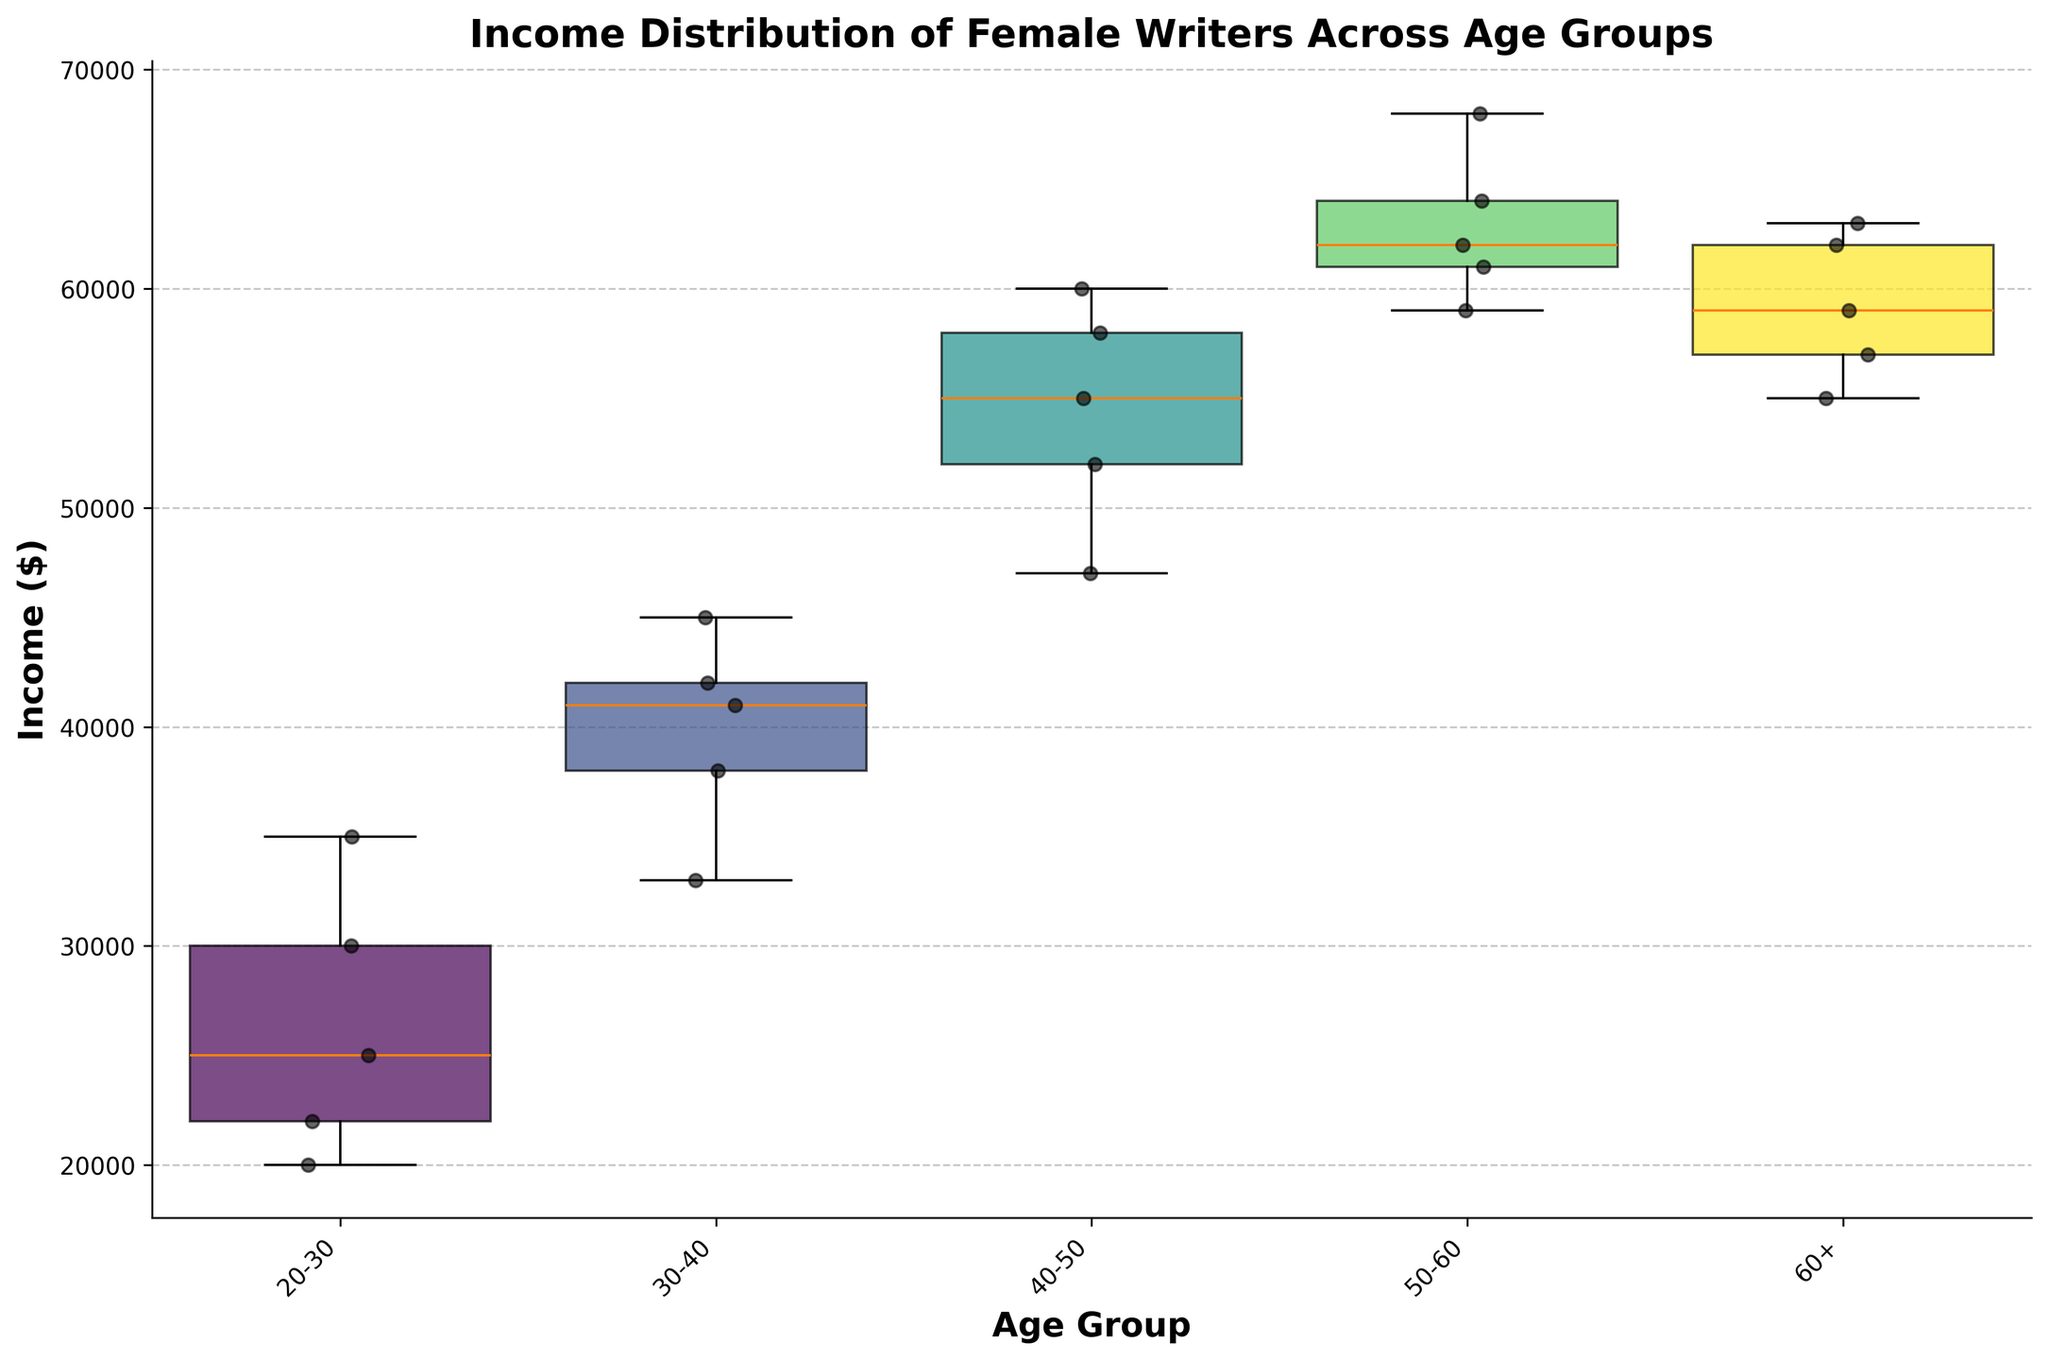What is the title of the figure? The title of the figure is typically located at the top center. It’s used to explain what the figure is about. Here, we can see that the title states "Income Distribution of Female Writers Across Age Groups".
Answer: Income Distribution of Female Writers Across Age Groups What does the x-axis represent? The x-axis label can be found on the horizontal line at the bottom of the plot. The label states that it represents "Age Group".
Answer: Age Group Which age group has the widest box plot? By observing the width of the box plots, the age group 20-30 has the widest box. The width corresponds to the number of data points for each age group.
Answer: 20-30 What is the general trend in median income across the different age groups? To identify the trend, observe the middle line (median) within each box. We can see that the median income tends to increase as the age group increases.
Answer: Median income increases with age Which age group shows the highest variability in income? Variability in income can be determined by looking at the interquartile range (IQR), which is the distance between the top and bottom of each box. The 50-60 age group has the largest IQR, indicating the highest variability.
Answer: 50-60 How does the number of data points affect the width of each box plot? Each box plot's width is determined by the number of data points within each age group. The wider the box plot, the more data points it includes. Age groups like 20-30 have more data points, making the box plot wider.
Answer: Wider boxes have more data points What is the median income for the 40-50 age group? The median is represented by the line within the 40-50 age group’s box. It appears to be around $55,000.
Answer: $55,000 How do the full-time freelancers' incomes compare across different age groups? By looking at the scatter points in each age group, the incomes for full-time freelancers seem to increase as age progresses, with higher incomes seen in older age groups.
Answer: Incomes increase with age Which employment status seems to have the highest incomes overall? Observing the scatter points' height, it's noticeable that full-time freelancers consistently have higher incomes compared to other employment statuses across all age groups.
Answer: Full-time Freelance Do any outliers exist in the income levels? In box plots, any points outside the “whiskers” can be considered outliers. In this case, there doesn't appear to be any significant outliers in terms of income level.
Answer: No 